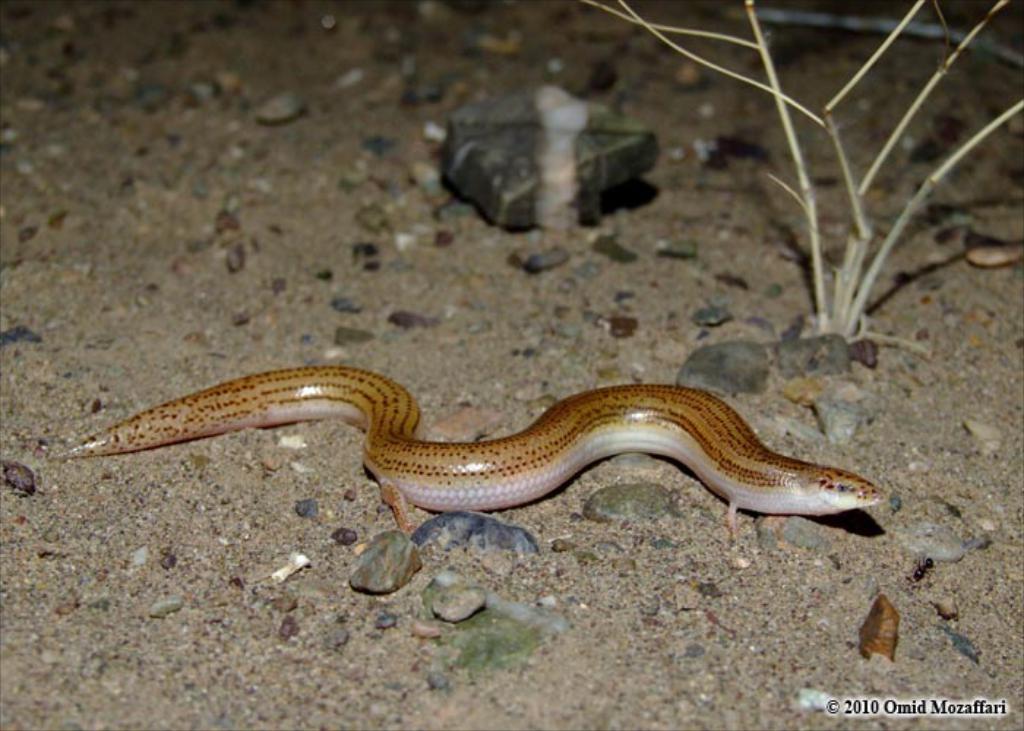How would you summarize this image in a sentence or two? In this image there is a snake, on a sand surface, in the background there is a plant, in the bottom right there is text. 